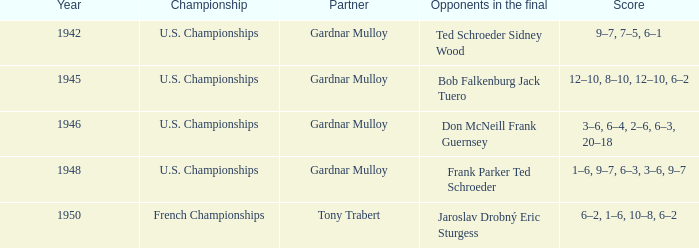What is the most recent year gardnar mulloy played as a partner and score was 12–10, 8–10, 12–10, 6–2? 1945.0. 